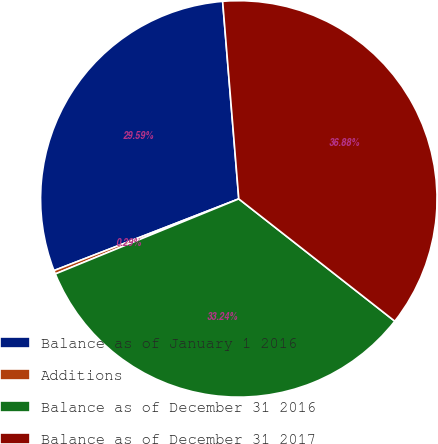Convert chart to OTSL. <chart><loc_0><loc_0><loc_500><loc_500><pie_chart><fcel>Balance as of January 1 2016<fcel>Additions<fcel>Balance as of December 31 2016<fcel>Balance as of December 31 2017<nl><fcel>29.59%<fcel>0.29%<fcel>33.24%<fcel>36.88%<nl></chart> 